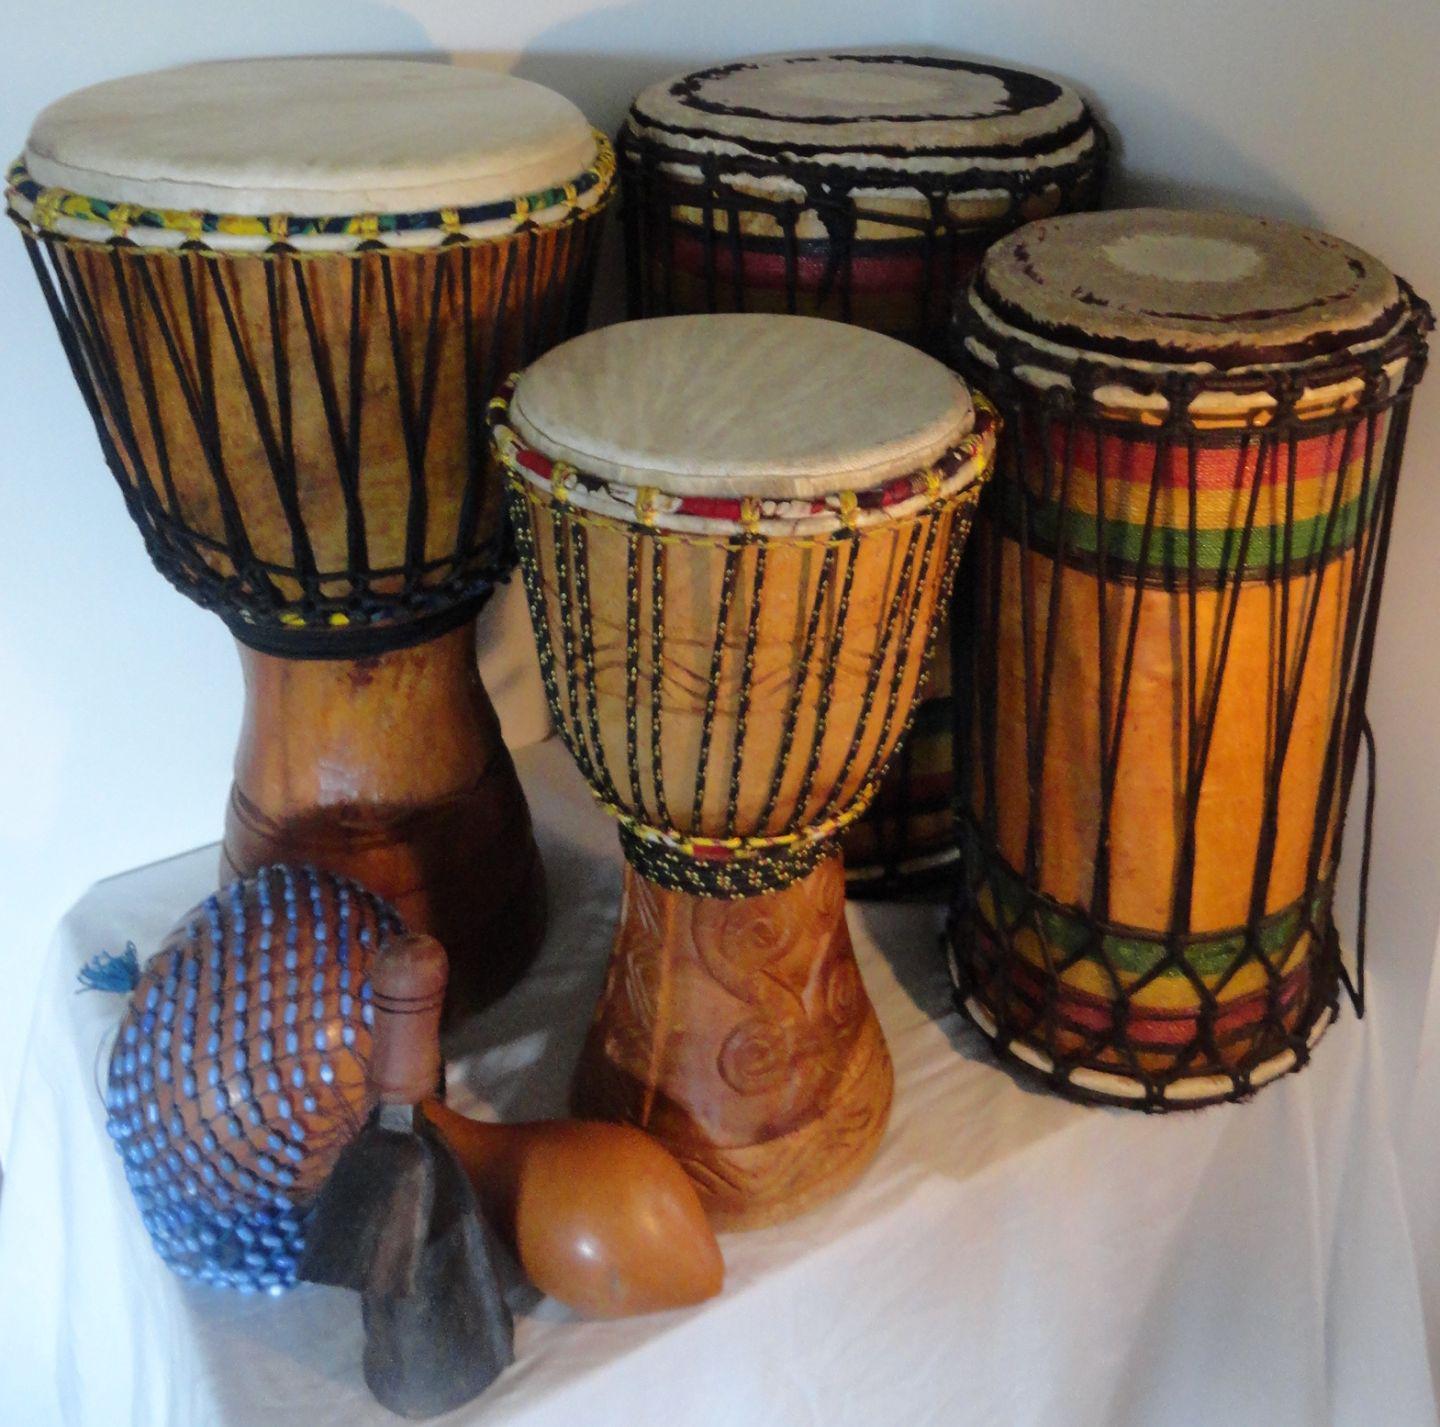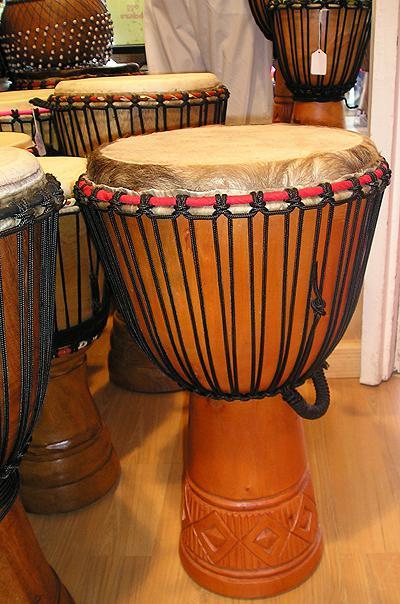The first image is the image on the left, the second image is the image on the right. Examine the images to the left and right. Is the description "The left and right image contains the same number of drums." accurate? Answer yes or no. No. The first image is the image on the left, the second image is the image on the right. For the images shown, is this caption "The drums in each image are standing upright." true? Answer yes or no. Yes. 